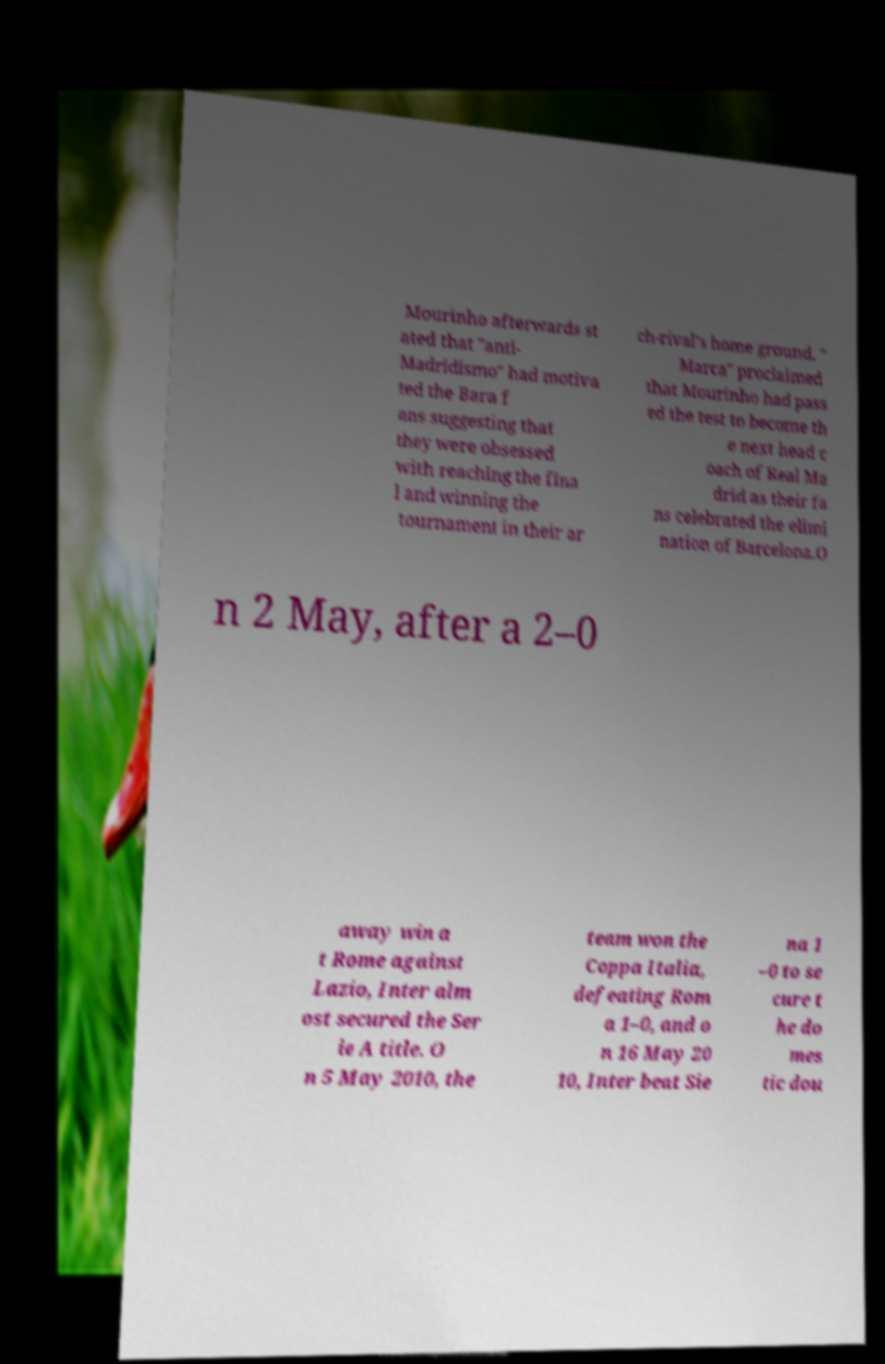Could you assist in decoding the text presented in this image and type it out clearly? Mourinho afterwards st ated that "anti- Madridismo" had motiva ted the Bara f ans suggesting that they were obsessed with reaching the fina l and winning the tournament in their ar ch-rival's home ground. " Marca" proclaimed that Mourinho had pass ed the test to become th e next head c oach of Real Ma drid as their fa ns celebrated the elimi nation of Barcelona.O n 2 May, after a 2–0 away win a t Rome against Lazio, Inter alm ost secured the Ser ie A title. O n 5 May 2010, the team won the Coppa Italia, defeating Rom a 1–0, and o n 16 May 20 10, Inter beat Sie na 1 –0 to se cure t he do mes tic dou 